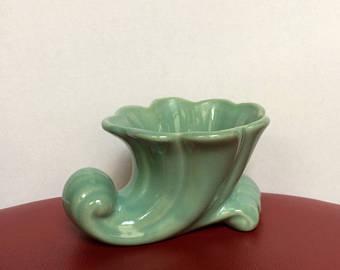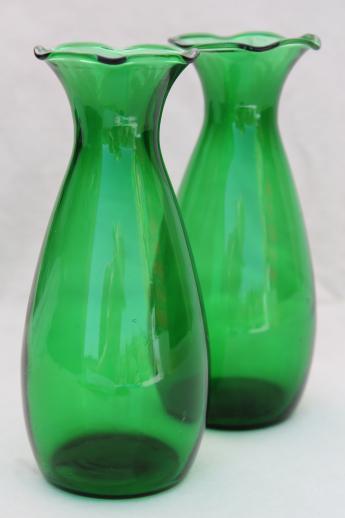The first image is the image on the left, the second image is the image on the right. Examine the images to the left and right. Is the description "The left image shows one vase that tapers to a wave-curl at its bottom, and the right image shows at least one vase with a rounded bottom and no curl." accurate? Answer yes or no. Yes. The first image is the image on the left, the second image is the image on the right. Assess this claim about the two images: "The right image contains two glass sculptures.". Correct or not? Answer yes or no. Yes. 